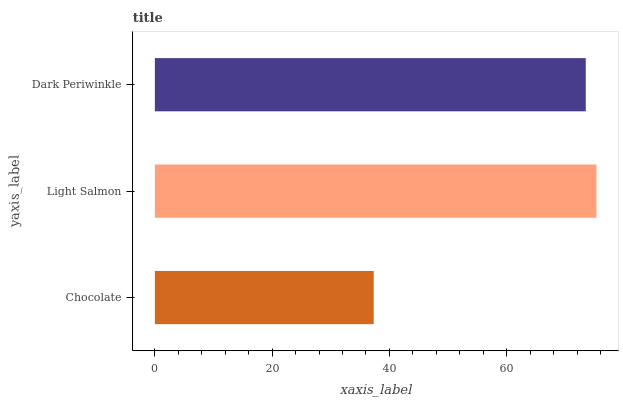Is Chocolate the minimum?
Answer yes or no. Yes. Is Light Salmon the maximum?
Answer yes or no. Yes. Is Dark Periwinkle the minimum?
Answer yes or no. No. Is Dark Periwinkle the maximum?
Answer yes or no. No. Is Light Salmon greater than Dark Periwinkle?
Answer yes or no. Yes. Is Dark Periwinkle less than Light Salmon?
Answer yes or no. Yes. Is Dark Periwinkle greater than Light Salmon?
Answer yes or no. No. Is Light Salmon less than Dark Periwinkle?
Answer yes or no. No. Is Dark Periwinkle the high median?
Answer yes or no. Yes. Is Dark Periwinkle the low median?
Answer yes or no. Yes. Is Chocolate the high median?
Answer yes or no. No. Is Chocolate the low median?
Answer yes or no. No. 